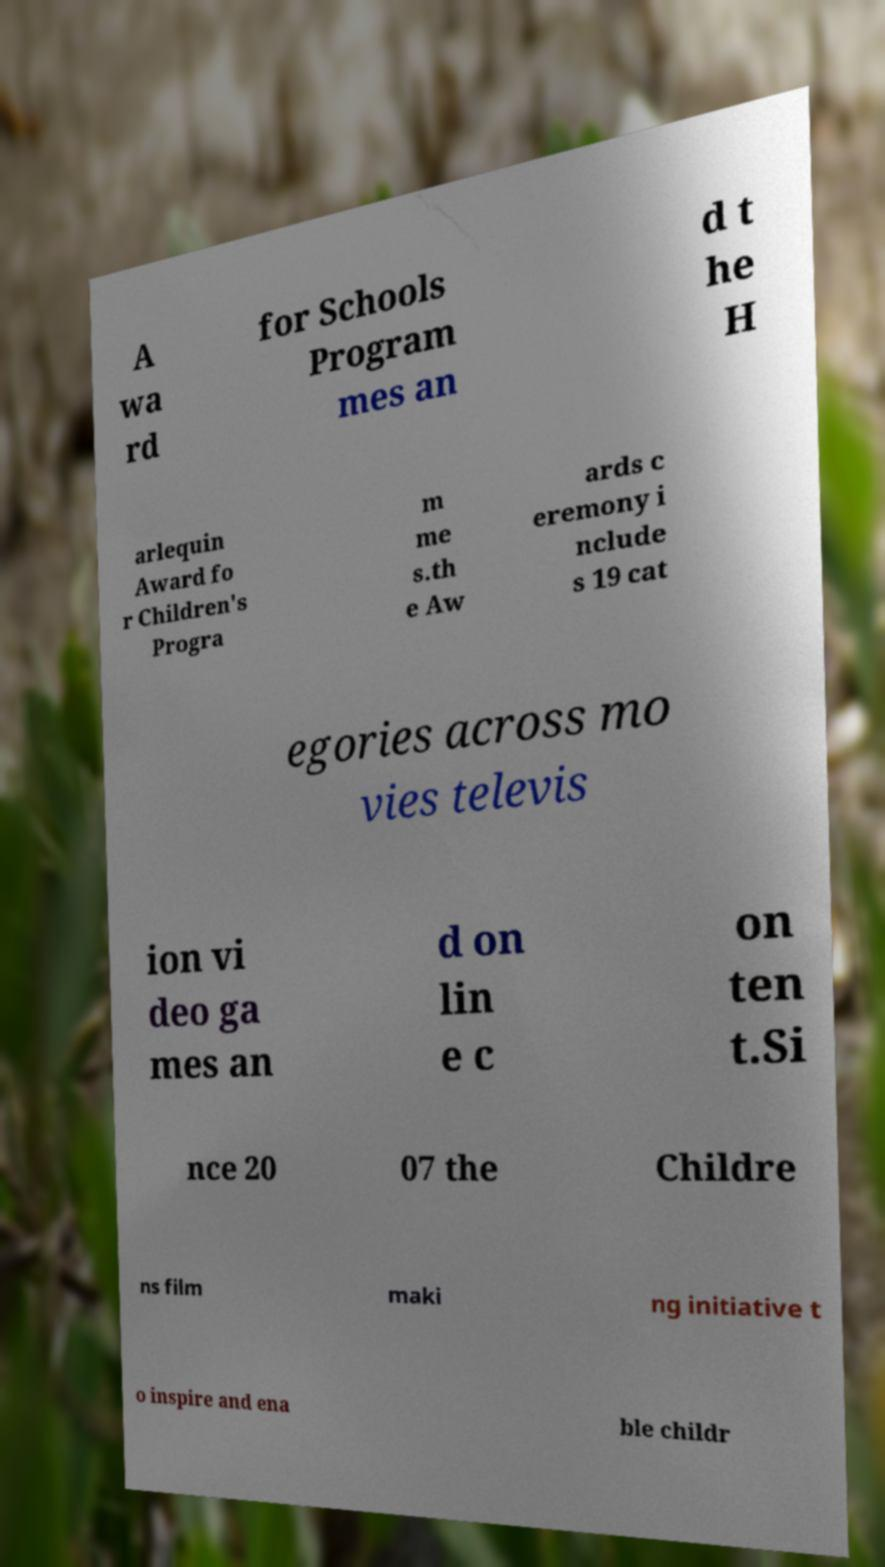What messages or text are displayed in this image? I need them in a readable, typed format. A wa rd for Schools Program mes an d t he H arlequin Award fo r Children's Progra m me s.th e Aw ards c eremony i nclude s 19 cat egories across mo vies televis ion vi deo ga mes an d on lin e c on ten t.Si nce 20 07 the Childre ns film maki ng initiative t o inspire and ena ble childr 